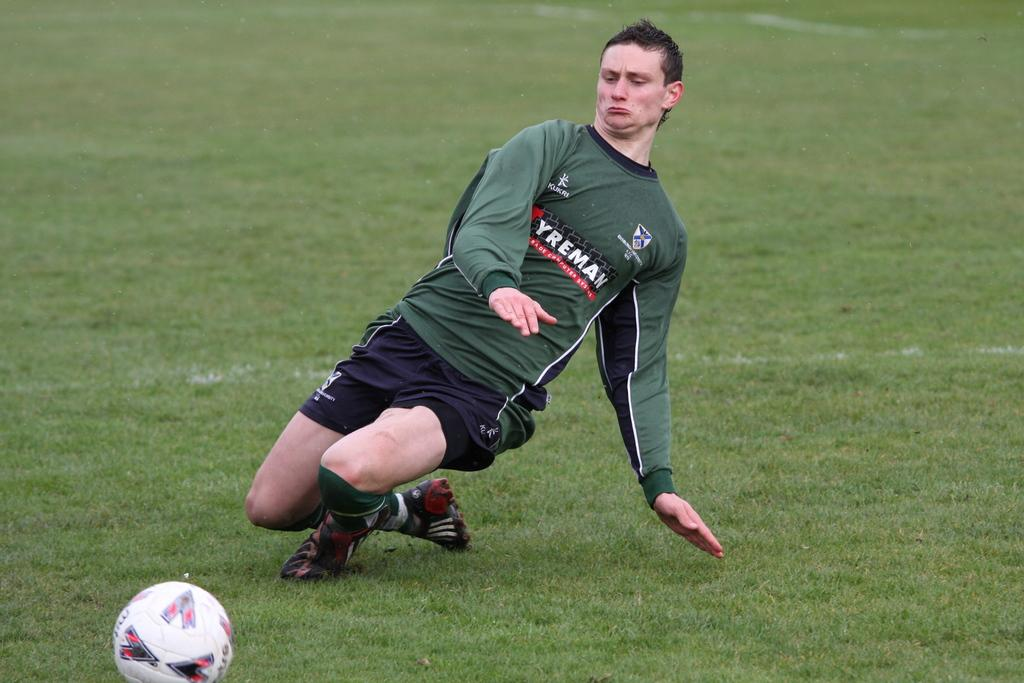Who or what is the main subject in the image? There is a person in the image. Can you describe the person's attire? The person is wearing a green and black color dress. What object is in front of the person? There is a ball in front of the person. What is the color of the grass in the image? The grass is green in color. Where is the shelf located in the image? There is no shelf present in the image. What type of rail is visible in the image? There is no rail present in the image. 